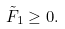<formula> <loc_0><loc_0><loc_500><loc_500>\tilde { F } _ { 1 } \geq 0 .</formula> 